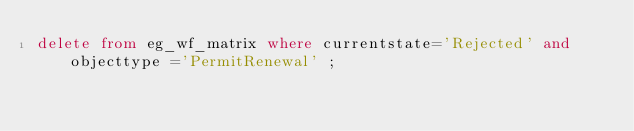Convert code to text. <code><loc_0><loc_0><loc_500><loc_500><_SQL_>delete from eg_wf_matrix where currentstate='Rejected' and objecttype ='PermitRenewal' ;</code> 